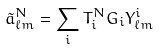<formula> <loc_0><loc_0><loc_500><loc_500>\tilde { a } _ { \ell m } ^ { N } = \sum _ { i } T _ { i } ^ { N } G _ { i } Y _ { \ell m } ^ { i }</formula> 